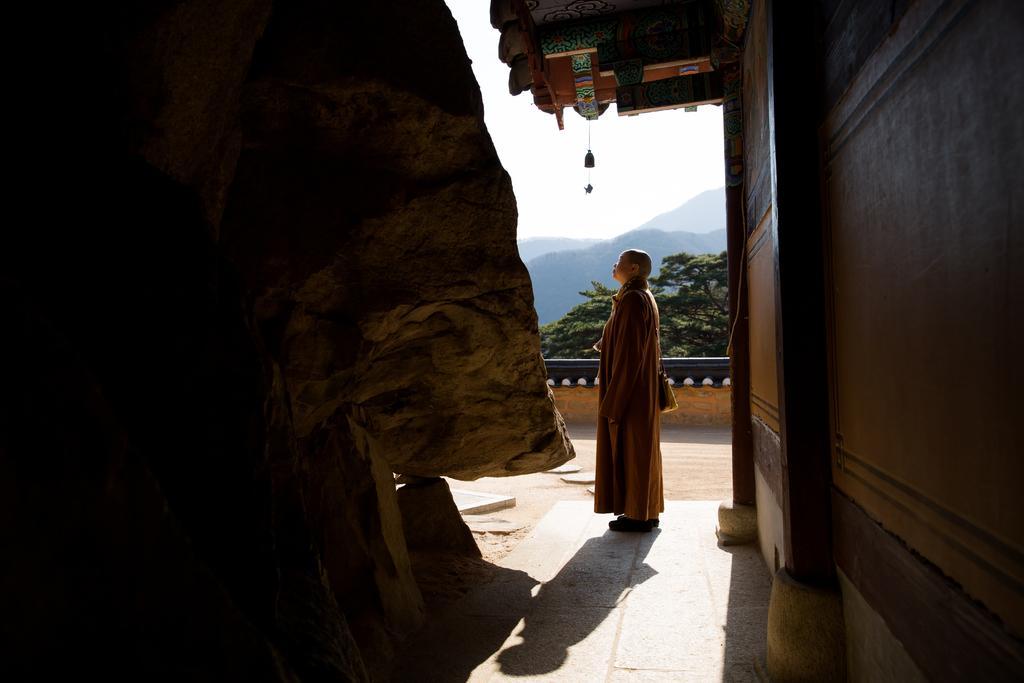Describe this image in one or two sentences. In this picture I can observe a person standing on the land. On the left side I can observe a large stone. On the right side there is a house. In the background there are trees, hills and a sky. 